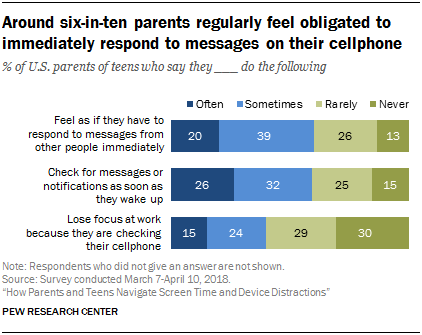Indicate a few pertinent items in this graphic. The color of the last section of the bar graph is green. The total value of all the three-bar graphs where the "Never" value is 58 is 58. 